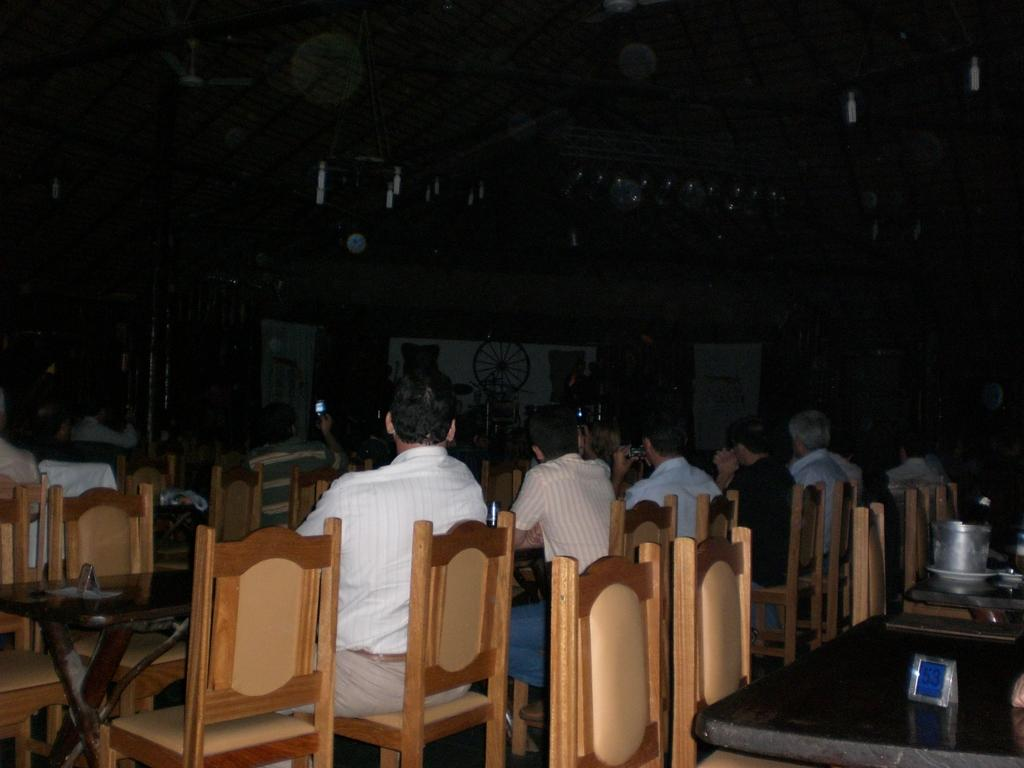What is happening in the image? There is a group of people in the image. How are the people positioned in the image? The people are seated on chairs. Can you describe the furniture in the image? There are at least two tables in the image. What type of stove can be seen in the image? There is no stove present in the image. How comfortable are the chairs in the image? The comfort level of the chairs cannot be determined from the image alone. 